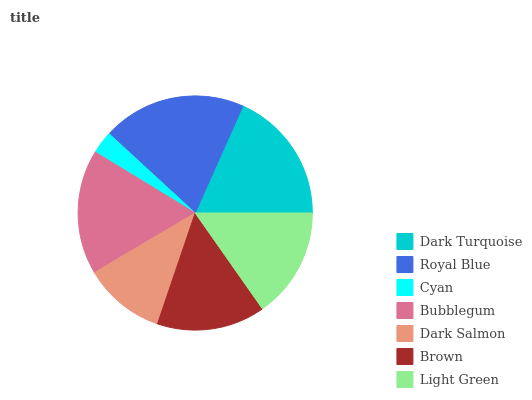Is Cyan the minimum?
Answer yes or no. Yes. Is Royal Blue the maximum?
Answer yes or no. Yes. Is Royal Blue the minimum?
Answer yes or no. No. Is Cyan the maximum?
Answer yes or no. No. Is Royal Blue greater than Cyan?
Answer yes or no. Yes. Is Cyan less than Royal Blue?
Answer yes or no. Yes. Is Cyan greater than Royal Blue?
Answer yes or no. No. Is Royal Blue less than Cyan?
Answer yes or no. No. Is Light Green the high median?
Answer yes or no. Yes. Is Light Green the low median?
Answer yes or no. Yes. Is Dark Salmon the high median?
Answer yes or no. No. Is Cyan the low median?
Answer yes or no. No. 